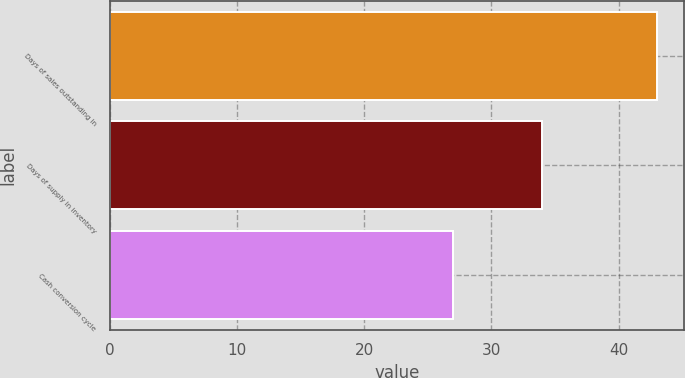Convert chart. <chart><loc_0><loc_0><loc_500><loc_500><bar_chart><fcel>Days of sales outstanding in<fcel>Days of supply in inventory<fcel>Cash conversion cycle<nl><fcel>43<fcel>34<fcel>27<nl></chart> 